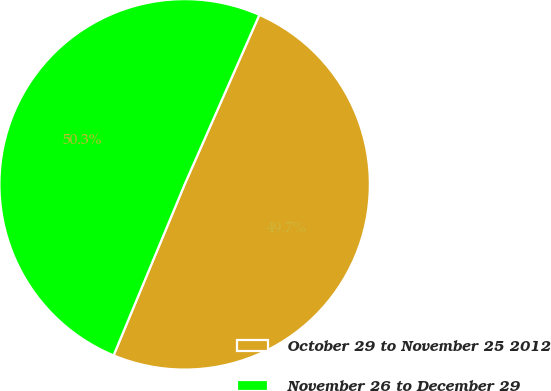Convert chart to OTSL. <chart><loc_0><loc_0><loc_500><loc_500><pie_chart><fcel>October 29 to November 25 2012<fcel>November 26 to December 29<nl><fcel>49.66%<fcel>50.34%<nl></chart> 